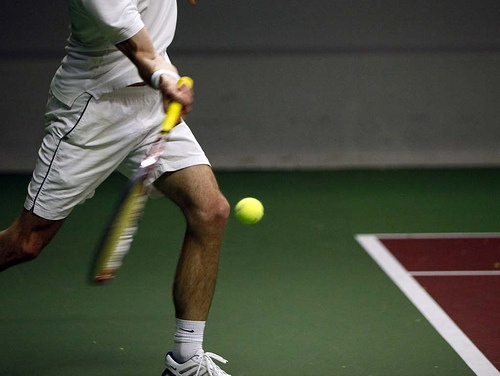Describe the objects in this image and their specific colors. I can see people in black, darkgray, gray, and lightgray tones, tennis racket in black, olive, gray, and darkgray tones, and sports ball in black, khaki, and darkgreen tones in this image. 